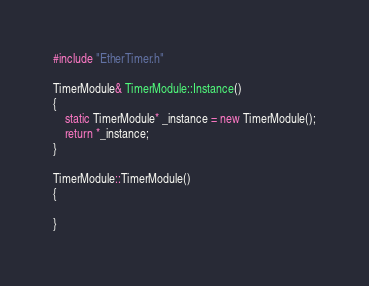<code> <loc_0><loc_0><loc_500><loc_500><_C++_>#include "EtherTimer.h"

TimerModule& TimerModule::Instance()
{
	static TimerModule* _instance = new TimerModule();
	return *_instance;
}

TimerModule::TimerModule()
{

}</code> 